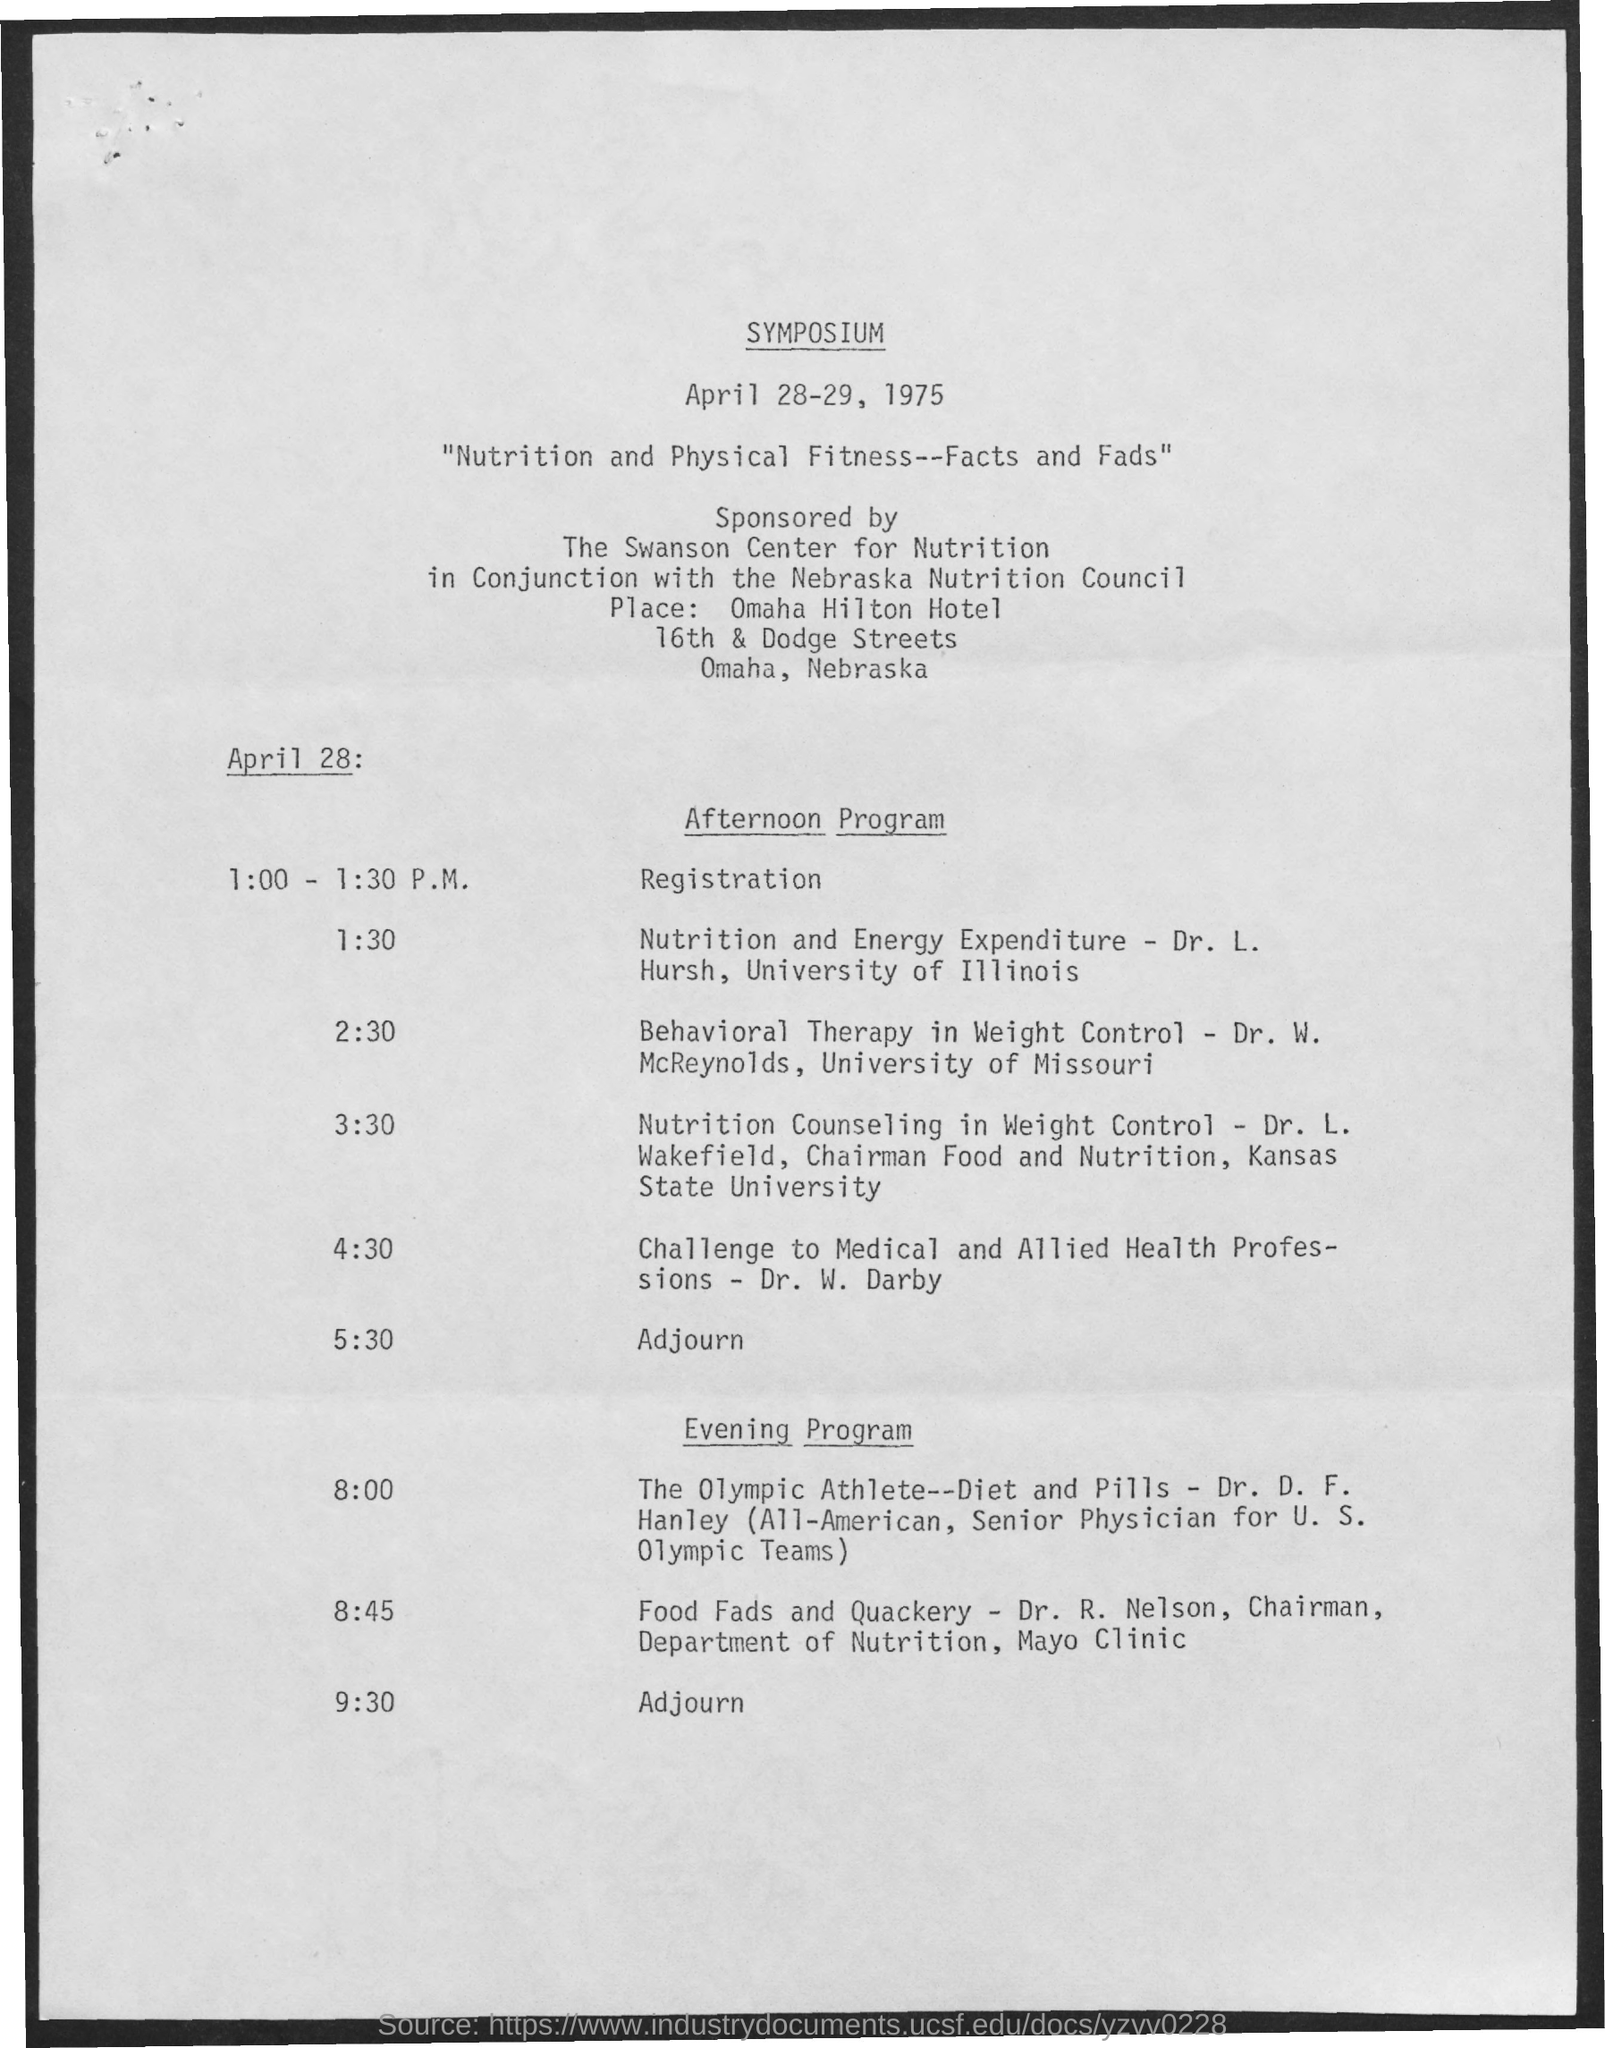What is the date mentioned ?
Your answer should be compact. April 28-29, 1975. What is the schedule at the time of 1:00 - 1:30 p.m. on april 28 ?
Your answer should be compact. REGISTRATION. 